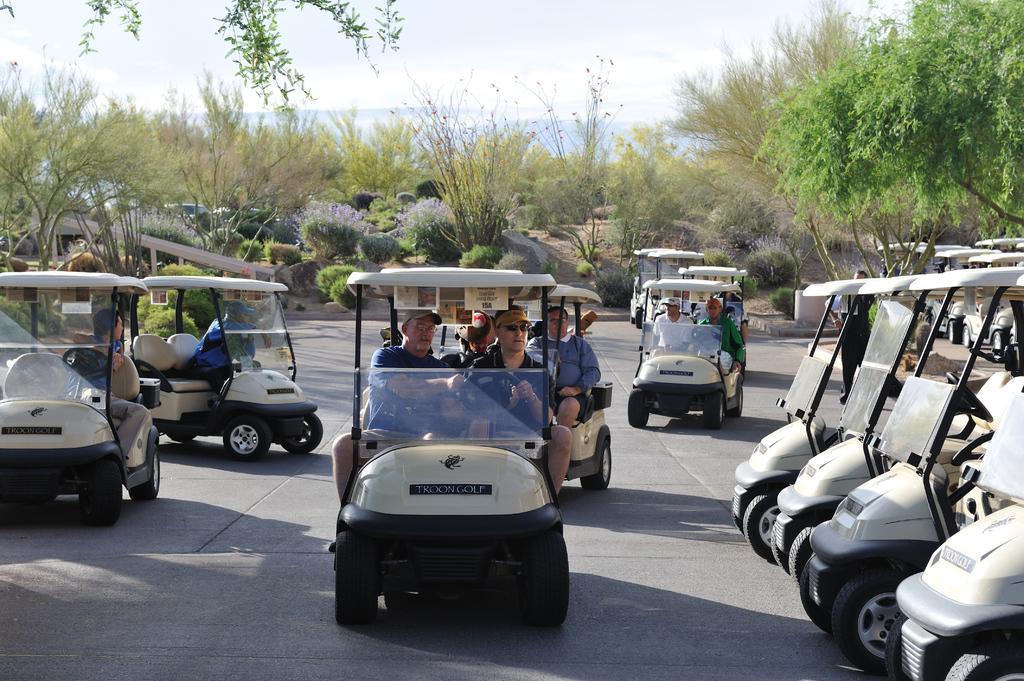Can you describe this image briefly? This picture is clicked outside. On the right corner we can see the vehicles parked on the ground. In the center we can see the group of persons riding the vehicles on the ground. In the background we can see the sky, trees, plants and some other objects. 